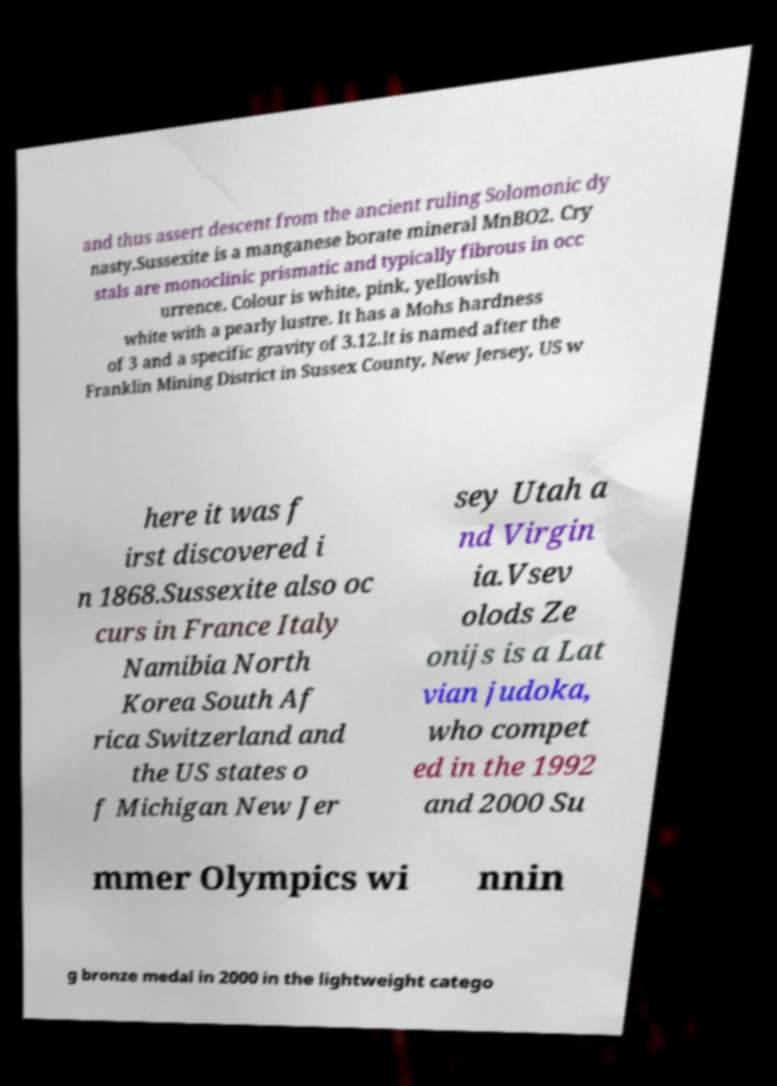Can you accurately transcribe the text from the provided image for me? and thus assert descent from the ancient ruling Solomonic dy nasty.Sussexite is a manganese borate mineral MnBO2. Cry stals are monoclinic prismatic and typically fibrous in occ urrence. Colour is white, pink, yellowish white with a pearly lustre. It has a Mohs hardness of 3 and a specific gravity of 3.12.It is named after the Franklin Mining District in Sussex County, New Jersey, US w here it was f irst discovered i n 1868.Sussexite also oc curs in France Italy Namibia North Korea South Af rica Switzerland and the US states o f Michigan New Jer sey Utah a nd Virgin ia.Vsev olods Ze onijs is a Lat vian judoka, who compet ed in the 1992 and 2000 Su mmer Olympics wi nnin g bronze medal in 2000 in the lightweight catego 